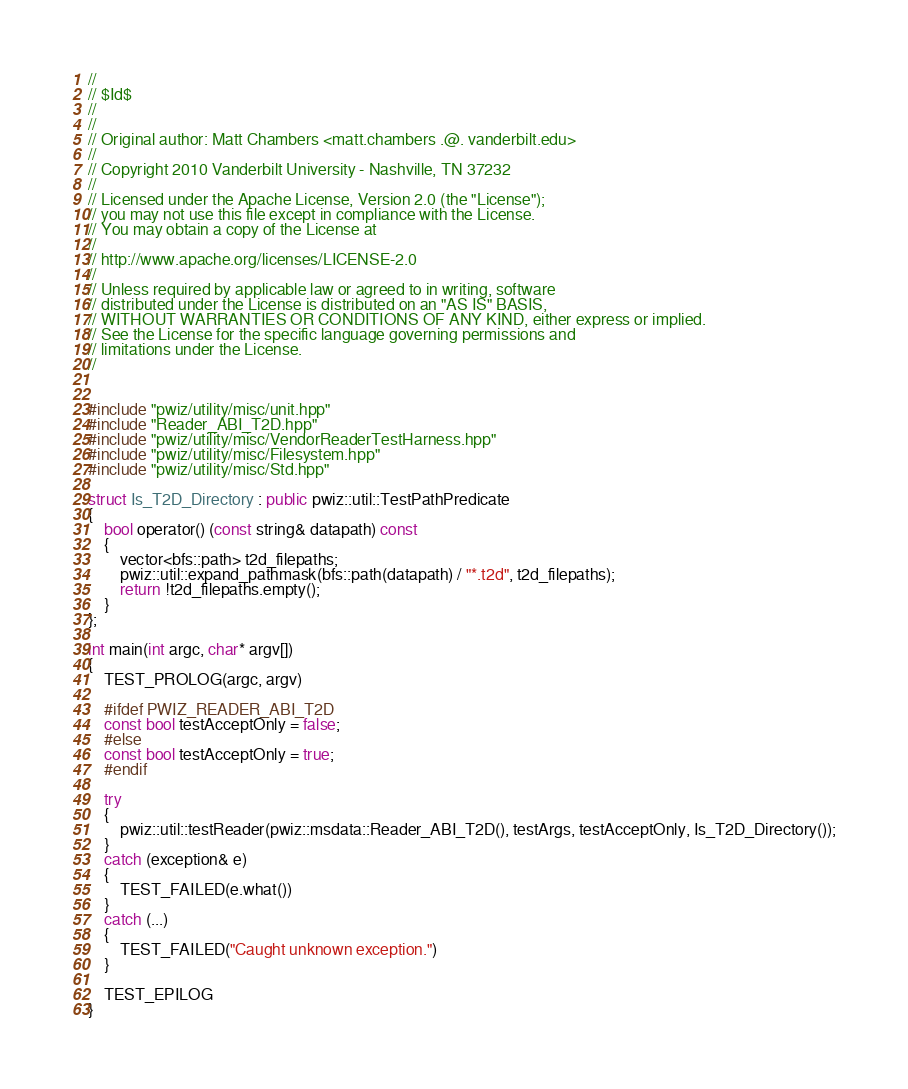<code> <loc_0><loc_0><loc_500><loc_500><_C++_>//
// $Id$
//
//
// Original author: Matt Chambers <matt.chambers .@. vanderbilt.edu>
//
// Copyright 2010 Vanderbilt University - Nashville, TN 37232
//
// Licensed under the Apache License, Version 2.0 (the "License"); 
// you may not use this file except in compliance with the License. 
// You may obtain a copy of the License at 
//
// http://www.apache.org/licenses/LICENSE-2.0
//
// Unless required by applicable law or agreed to in writing, software 
// distributed under the License is distributed on an "AS IS" BASIS, 
// WITHOUT WARRANTIES OR CONDITIONS OF ANY KIND, either express or implied. 
// See the License for the specific language governing permissions and 
// limitations under the License.
//


#include "pwiz/utility/misc/unit.hpp"
#include "Reader_ABI_T2D.hpp"
#include "pwiz/utility/misc/VendorReaderTestHarness.hpp"
#include "pwiz/utility/misc/Filesystem.hpp"
#include "pwiz/utility/misc/Std.hpp"

struct Is_T2D_Directory : public pwiz::util::TestPathPredicate
{
    bool operator() (const string& datapath) const
    {
        vector<bfs::path> t2d_filepaths;
        pwiz::util::expand_pathmask(bfs::path(datapath) / "*.t2d", t2d_filepaths);
        return !t2d_filepaths.empty();
    }
};

int main(int argc, char* argv[])
{
    TEST_PROLOG(argc, argv)

    #ifdef PWIZ_READER_ABI_T2D
    const bool testAcceptOnly = false;
    #else
    const bool testAcceptOnly = true;
    #endif

    try
    {
        pwiz::util::testReader(pwiz::msdata::Reader_ABI_T2D(), testArgs, testAcceptOnly, Is_T2D_Directory());
    }
    catch (exception& e)
    {
        TEST_FAILED(e.what())
    }
    catch (...)
    {
        TEST_FAILED("Caught unknown exception.")
    }

    TEST_EPILOG
}
</code> 